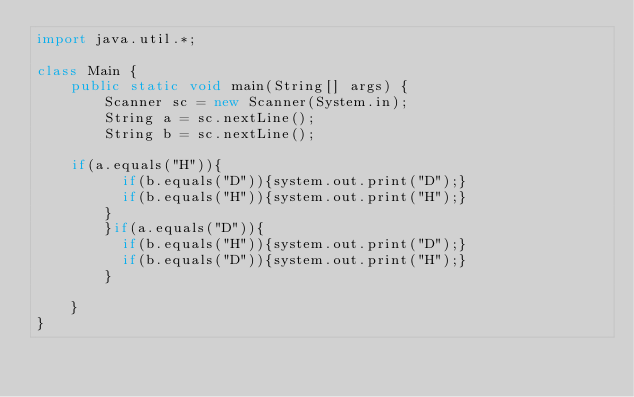<code> <loc_0><loc_0><loc_500><loc_500><_Java_>import java.util.*;
 
class Main {
    public static void main(String[] args) {
        Scanner sc = new Scanner(System.in);
        String a = sc.nextLine();
        String b = sc.nextLine();
       
		if(a.equals("H")){
          if(b.equals("D")){system.out.print("D");}
          if(b.equals("H")){system.out.print("H");}
        }
        }if(a.equals("D")){
          if(b.equals("H")){system.out.print("D");}
          if(b.equals("D")){system.out.print("H");}
        }
      
    }
}</code> 